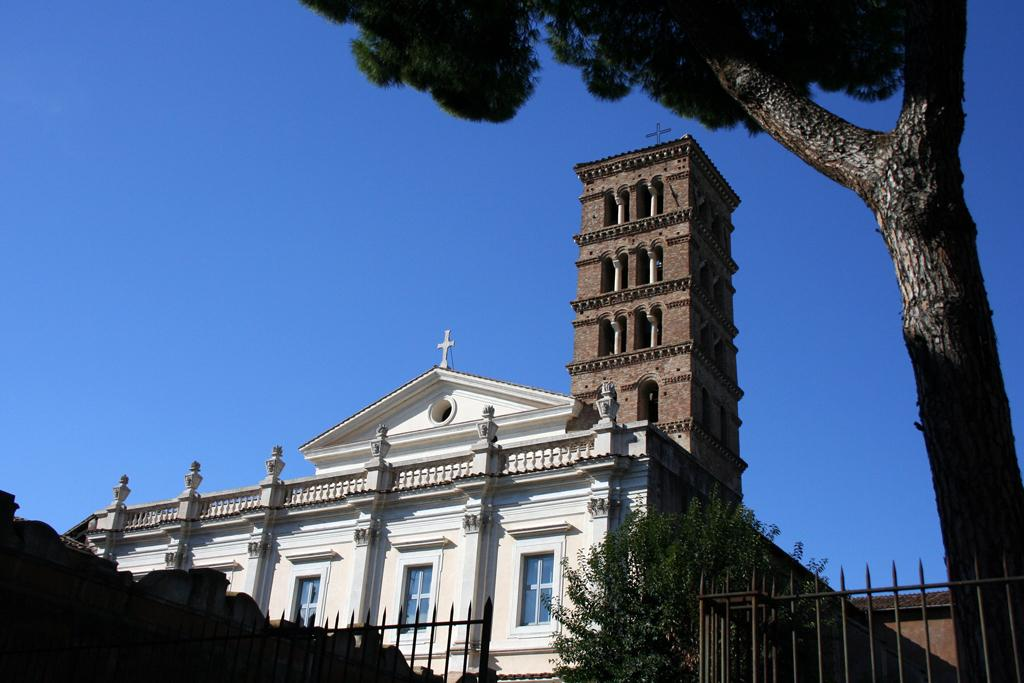What type of barrier can be seen in the image? There is a metal fence in the image. What type of vegetation is present in the image? There are trees in the image. What can be seen in the distance in the image? There are buildings in the background of the image. What is visible in the sky in the image? The sky is visible in the background of the image. How many parcels are being delivered by the cats in the image? There are no cats or parcels present in the image. What type of breakfast food is being prepared in the image? There is no breakfast food or preparation visible in the image. 